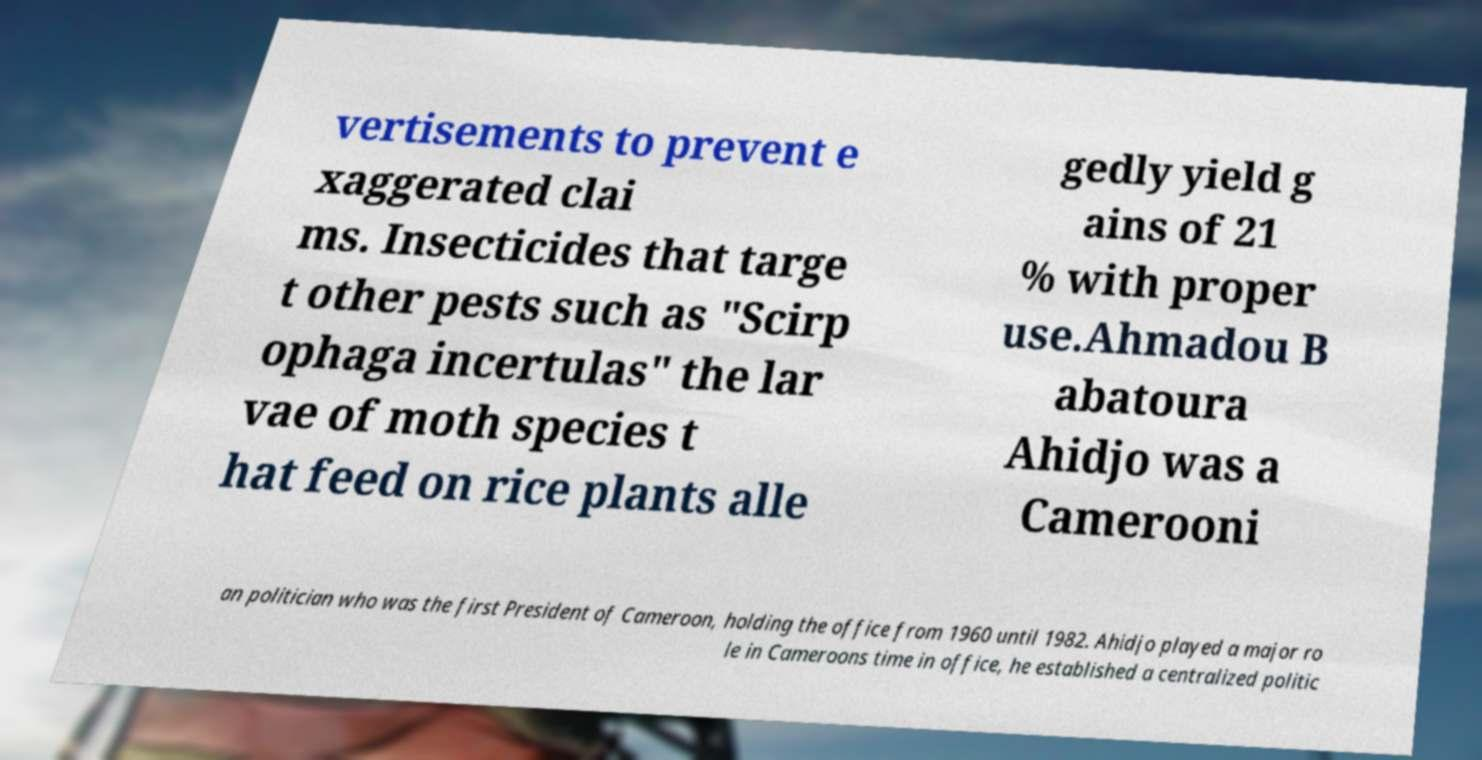For documentation purposes, I need the text within this image transcribed. Could you provide that? vertisements to prevent e xaggerated clai ms. Insecticides that targe t other pests such as "Scirp ophaga incertulas" the lar vae of moth species t hat feed on rice plants alle gedly yield g ains of 21 % with proper use.Ahmadou B abatoura Ahidjo was a Camerooni an politician who was the first President of Cameroon, holding the office from 1960 until 1982. Ahidjo played a major ro le in Cameroons time in office, he established a centralized politic 